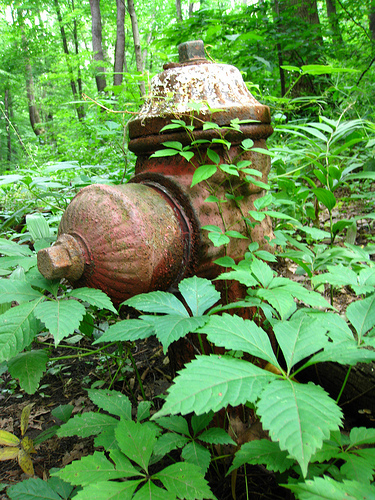If this image was a scene in a movie, what would be happening? In a movie scene featuring this image, the fire hydrant could symbolize the past in a story about nature reclaiming urban spaces. The protagonist, perhaps an environmental historian, stumbles upon it while exploring the forgotten remnants of an old town. This discovery sparks a journey through the history of the place, revealing a poignant tale of nature, time, and human impact. Write a dialogue between two characters discovering this hydrant for the first time. Alex: "Wow, look at this! It's an old fire hydrant. Must've been here for ages!"
Jamie: "It’s amazing how nature has taken over. You'd almost miss it if you didn’t look closely."
Alex: "I wonder what stories it could tell. Bet it has seen quite a few things in its time."
Jamie: "Yeah, it’s like a hidden piece of history. Think about the people who built this and what this place must have been like."
Alex: "It's both eerie and beautiful, isn't it? Makes you respect how powerful nature is." 